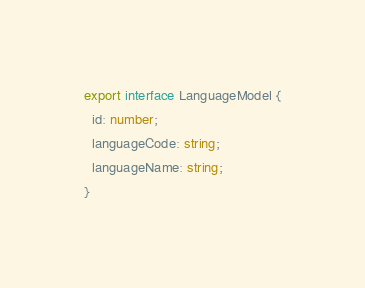Convert code to text. <code><loc_0><loc_0><loc_500><loc_500><_TypeScript_>export interface LanguageModel {
  id: number;
  languageCode: string;
  languageName: string;
}
</code> 